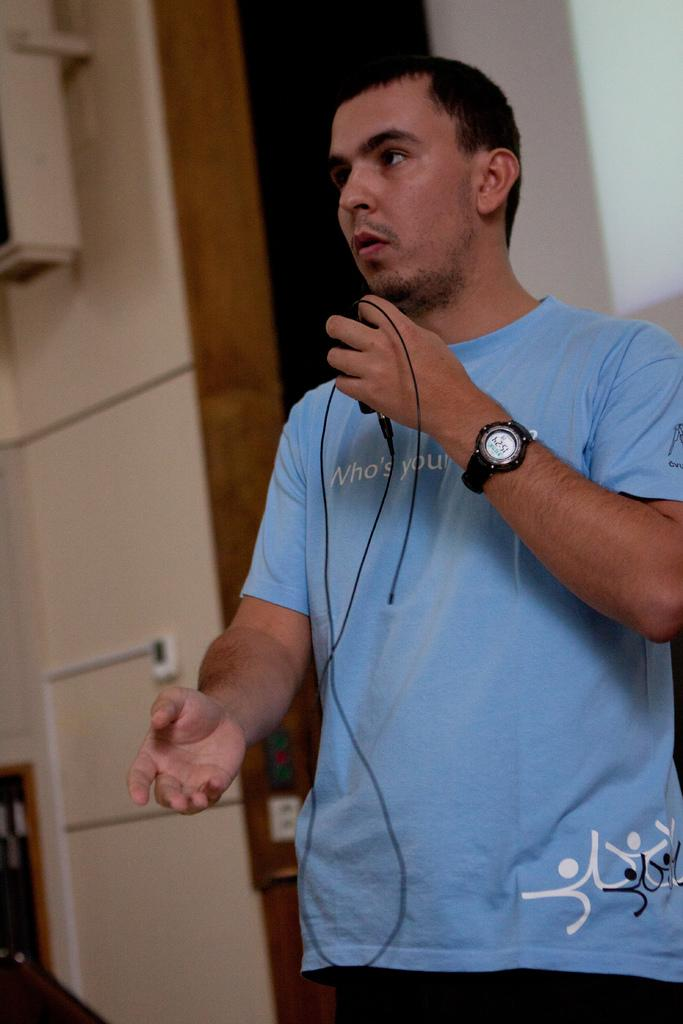What can be seen in the background of the image? There is a wall in the background of the image. Who is present in the image? There is a man in the image. What is the man wearing? The man is wearing a blue shirt. What is the man holding in his hand? The man is holding a charger in his hand. What accessory is the man wearing on his wrist? The man is wearing a watch. Is there any smoke coming from the man's mouth in the image? No, there is no smoke present in the image. How many bikes can be seen in the image? There are no bikes visible in the image. 